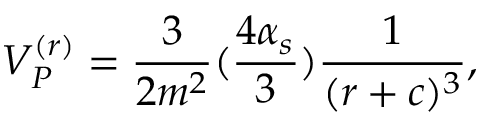<formula> <loc_0><loc_0><loc_500><loc_500>V _ { P } ^ { ( r ) } = { \frac { 3 } { 2 m ^ { 2 } } } ( { \frac { 4 \alpha _ { s } } { 3 } } ) { \frac { 1 } { ( r + c ) ^ { 3 } } } ,</formula> 